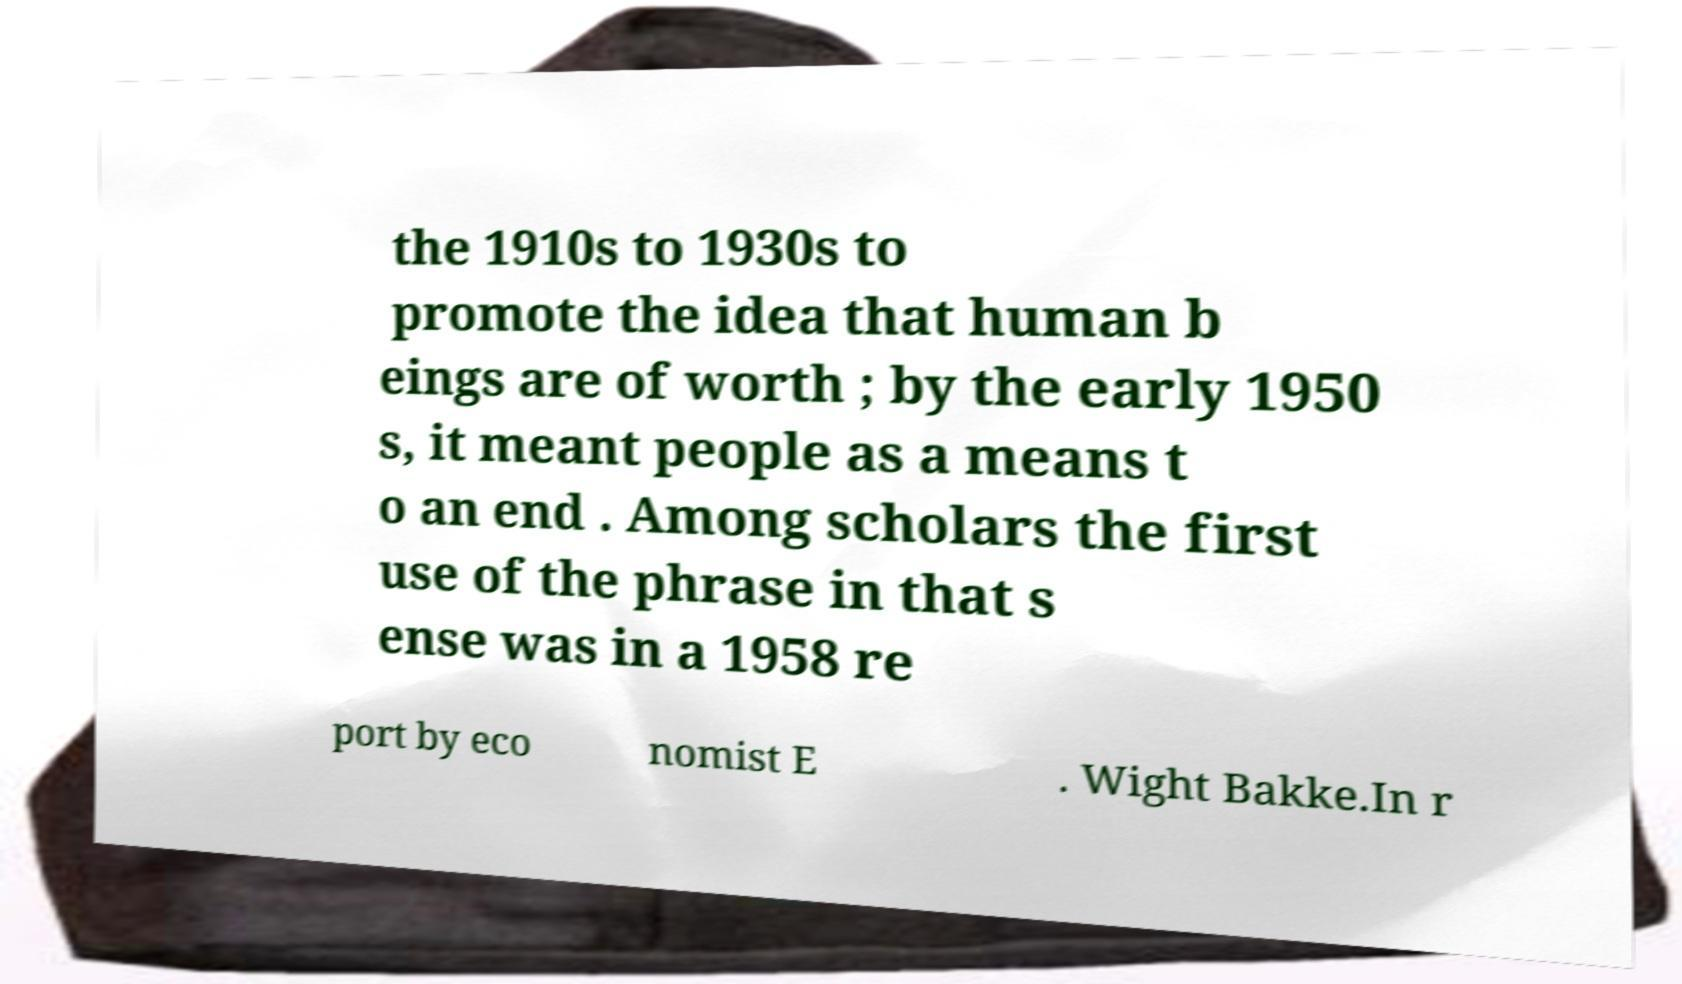Can you read and provide the text displayed in the image?This photo seems to have some interesting text. Can you extract and type it out for me? the 1910s to 1930s to promote the idea that human b eings are of worth ; by the early 1950 s, it meant people as a means t o an end . Among scholars the first use of the phrase in that s ense was in a 1958 re port by eco nomist E . Wight Bakke.In r 